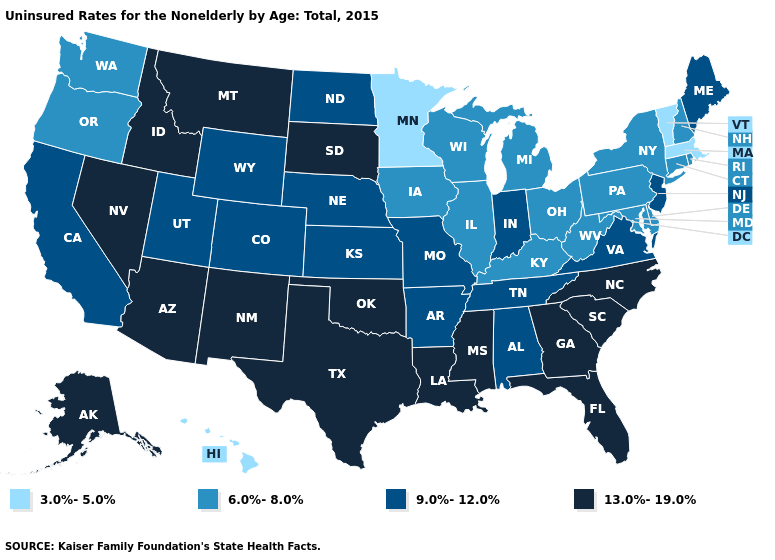What is the value of Maryland?
Write a very short answer. 6.0%-8.0%. Which states have the lowest value in the West?
Keep it brief. Hawaii. What is the value of Alaska?
Give a very brief answer. 13.0%-19.0%. Does Vermont have the same value as Massachusetts?
Write a very short answer. Yes. Name the states that have a value in the range 13.0%-19.0%?
Concise answer only. Alaska, Arizona, Florida, Georgia, Idaho, Louisiana, Mississippi, Montana, Nevada, New Mexico, North Carolina, Oklahoma, South Carolina, South Dakota, Texas. Does Nevada have the lowest value in the USA?
Be succinct. No. What is the value of South Carolina?
Quick response, please. 13.0%-19.0%. Does Alabama have the highest value in the South?
Answer briefly. No. Is the legend a continuous bar?
Keep it brief. No. What is the value of Minnesota?
Keep it brief. 3.0%-5.0%. Does Delaware have the lowest value in the South?
Write a very short answer. Yes. What is the value of Maine?
Concise answer only. 9.0%-12.0%. What is the value of North Dakota?
Write a very short answer. 9.0%-12.0%. Name the states that have a value in the range 6.0%-8.0%?
Short answer required. Connecticut, Delaware, Illinois, Iowa, Kentucky, Maryland, Michigan, New Hampshire, New York, Ohio, Oregon, Pennsylvania, Rhode Island, Washington, West Virginia, Wisconsin. Does Kentucky have a lower value than Minnesota?
Quick response, please. No. 